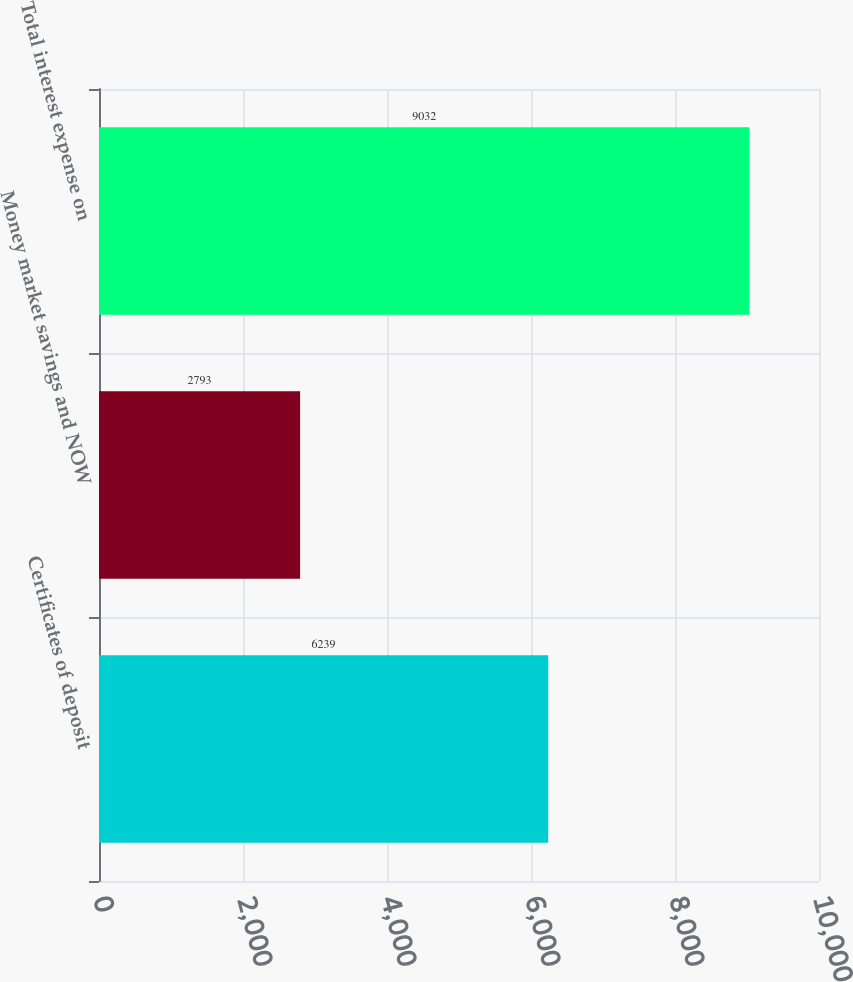Convert chart. <chart><loc_0><loc_0><loc_500><loc_500><bar_chart><fcel>Certificates of deposit<fcel>Money market savings and NOW<fcel>Total interest expense on<nl><fcel>6239<fcel>2793<fcel>9032<nl></chart> 